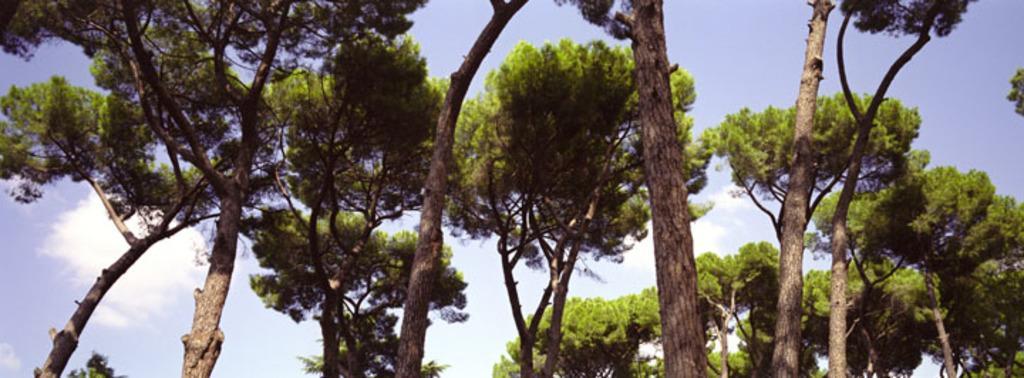How would you summarize this image in a sentence or two? In the foreground of the picture we can see trees. In the background there is sky. 